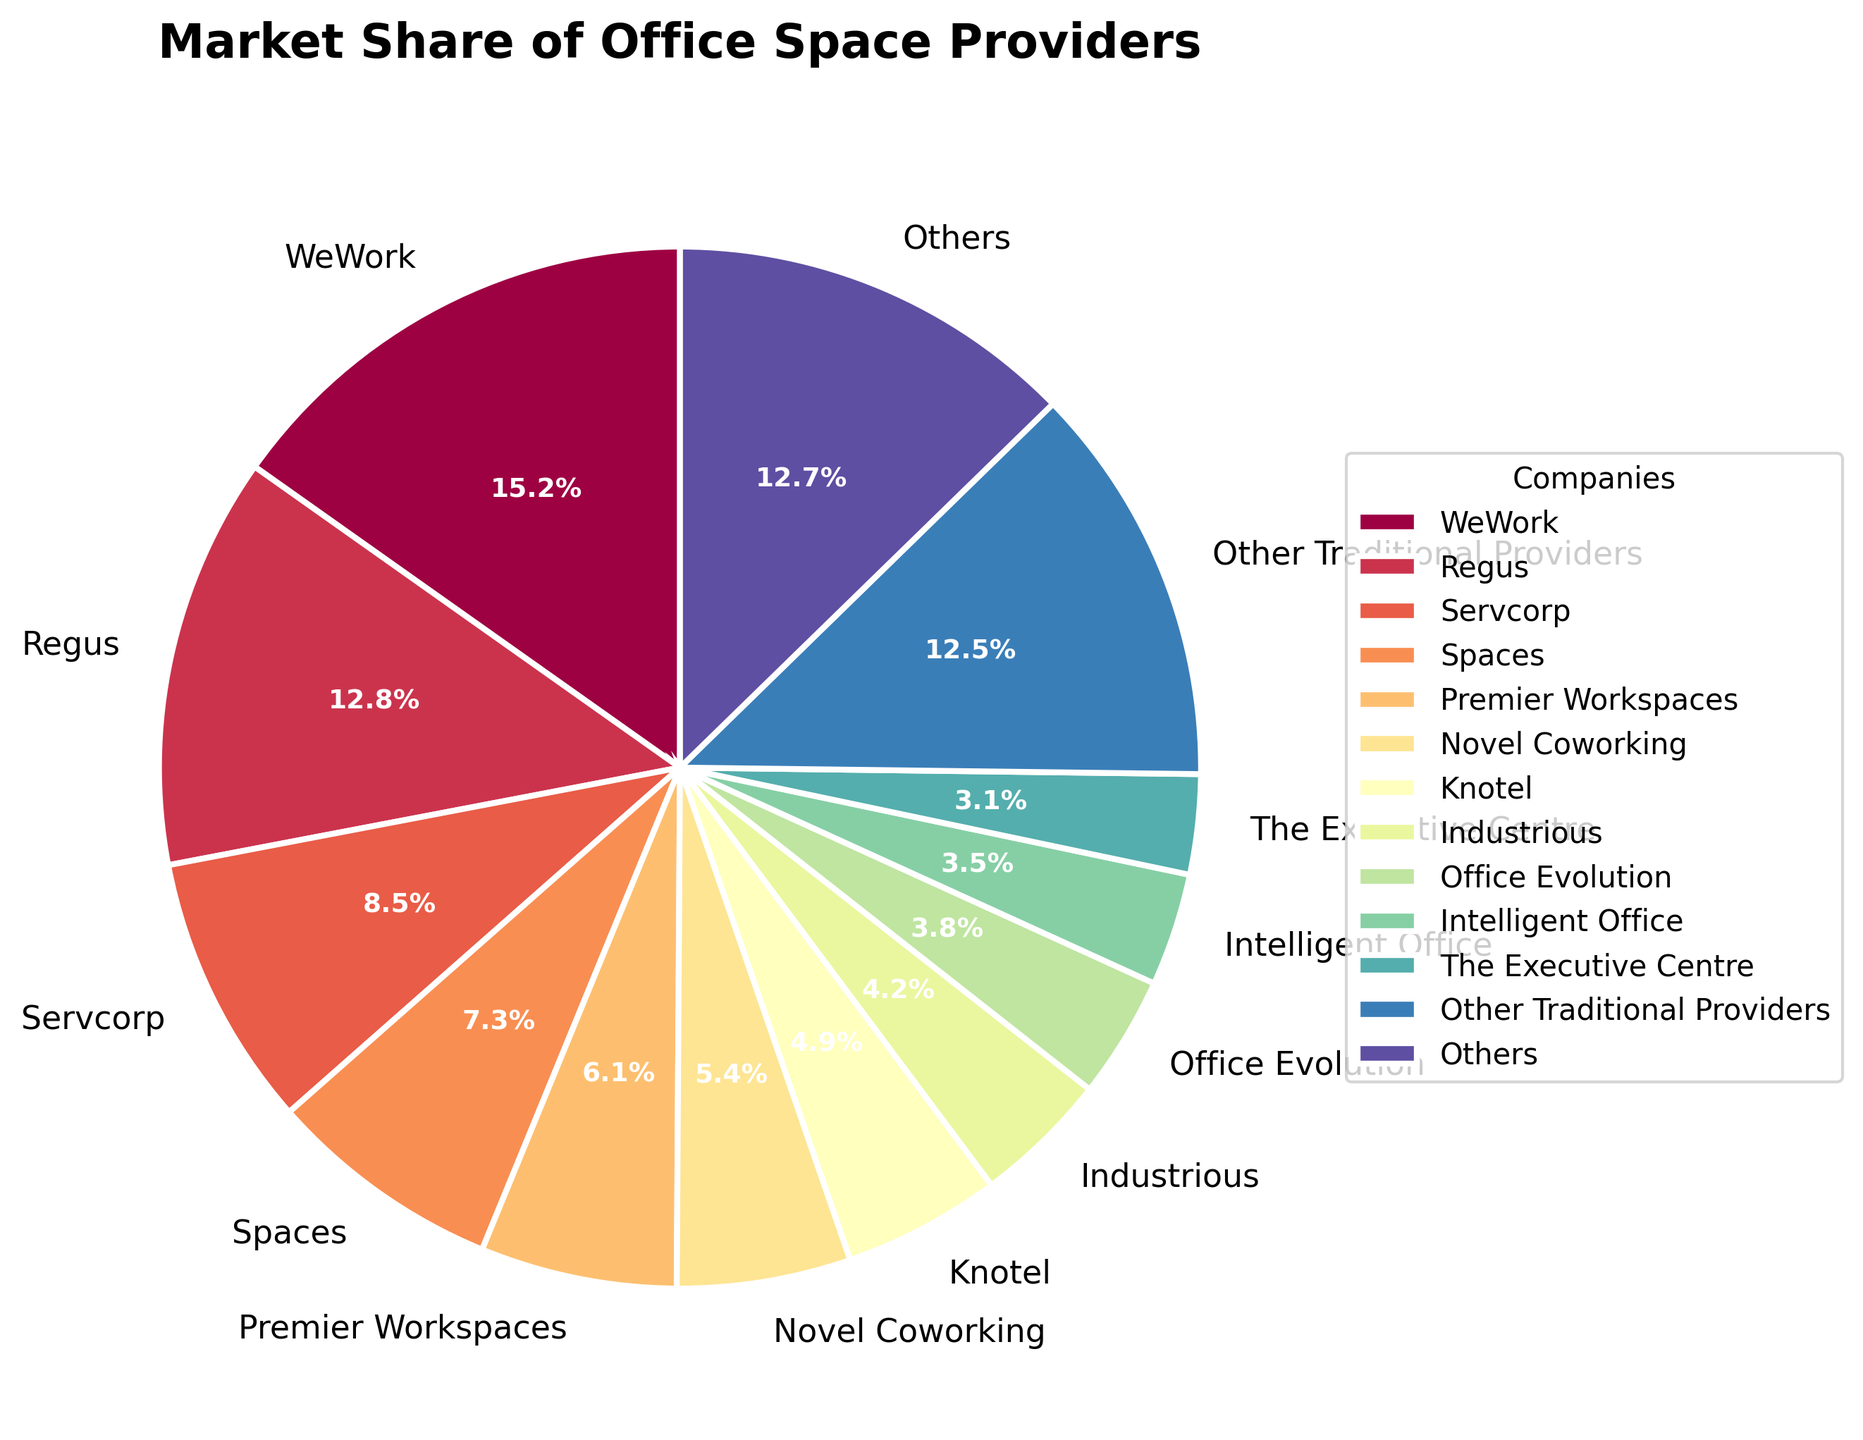Who holds the largest market share among the office space providers? The pie chart shows that WeWork has the largest segment.
Answer: WeWork Which company has a higher market share, Regus or Spaces? By comparing the pie chart segments, Regus has a larger portion than Spaces.
Answer: Regus What is the combined market share of Novel Coworking, Knotel, and Industrious? Sum the market shares of Novel Coworking (5.4%), Knotel (4.9%), and Industrious (4.2%): 5.4% + 4.9% + 4.2% = 14.5%.
Answer: 14.5% How does the market share of "Other Traditional Providers" compare to that of The Executive Centre? The chart shows that "Other Traditional Providers" has a significantly larger segment compared to The Executive Centre.
Answer: Other Traditional Providers Which has the smallest market share among the listed companies, excluding those grouped under "Others"? By looking at the segments individually, Opus Virtual Offices has the smallest market share with 1.4%.
Answer: Opus Virtual Offices Are the market shares of Premier Workspaces and Novel Coworking closer to each other than those of Convene and Breather? Comparing the segments, Premier Workspaces (6.1%) and Novel Coworking (5.4%) have a closer difference (0.7%) than Convene (2.7%) and Breather (2.3%) with a difference of (0.4%).
Answer: No What is the total market share of virtual office providers displayed in the pie chart? Sum the market shares of Davinci Virtual Office Solutions (1.9%), Alliance Virtual Offices (1.6%), and Opus Virtual Offices (1.4%), and "Other Virtual Office Providers" (2.8%): 1.9% + 1.6% + 1.4% + 2.8% = 7.7%.
Answer: 7.7% If the combined market share of "Other Traditional Providers" is added to WeWork's market share, what percentage of the market would they capture together? Sum WeWork's market share (15.2%) and "Other Traditional Providers" (12.5%): 15.2% + 12.5% = 27.7%.
Answer: 27.7% What visual characteristics differentiate the "Other" category from individual companies in the pie chart? The "Others" category is a single section combining smaller segments, usually shaded in a color similar to but distinct from individual companies to differentiate groups versus individuals.
Answer: Grouped segment 